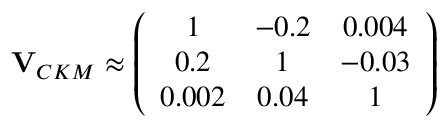<formula> <loc_0><loc_0><loc_500><loc_500>{ V } _ { C K M } \approx \left ( \begin{array} { c c c } { 1 } & { - 0 . 2 } & { 0 . 0 0 4 } \\ { 0 . 2 } & { 1 } & { - 0 . 0 3 } \\ { 0 . 0 0 2 } & { 0 . 0 4 } & { 1 } \end{array} \right )</formula> 